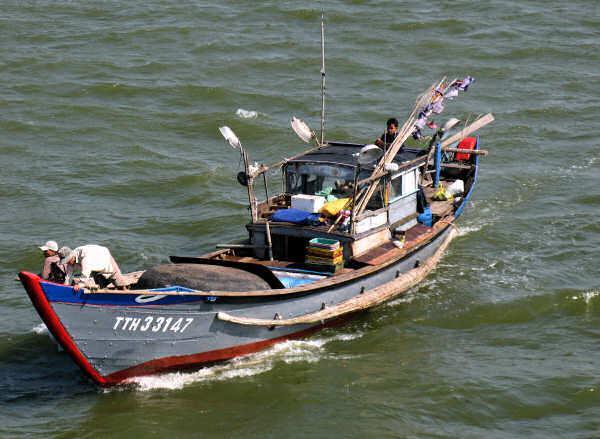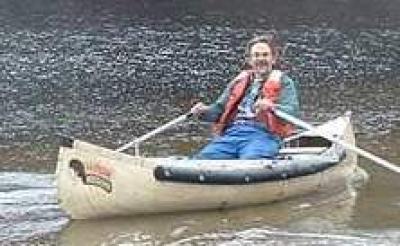The first image is the image on the left, the second image is the image on the right. Evaluate the accuracy of this statement regarding the images: "An image shows a man without a cap sitting in a traditional canoe gripping an oar in each hand, with his arms and body in position to pull the oars back.". Is it true? Answer yes or no. Yes. The first image is the image on the left, the second image is the image on the right. Examine the images to the left and right. Is the description "The left and right image contains the same number of small crafts in the water." accurate? Answer yes or no. Yes. 